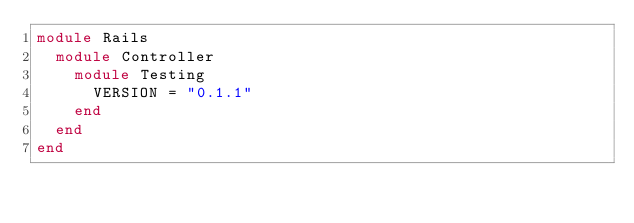Convert code to text. <code><loc_0><loc_0><loc_500><loc_500><_Ruby_>module Rails
  module Controller
    module Testing
      VERSION = "0.1.1"
    end
  end
end
</code> 